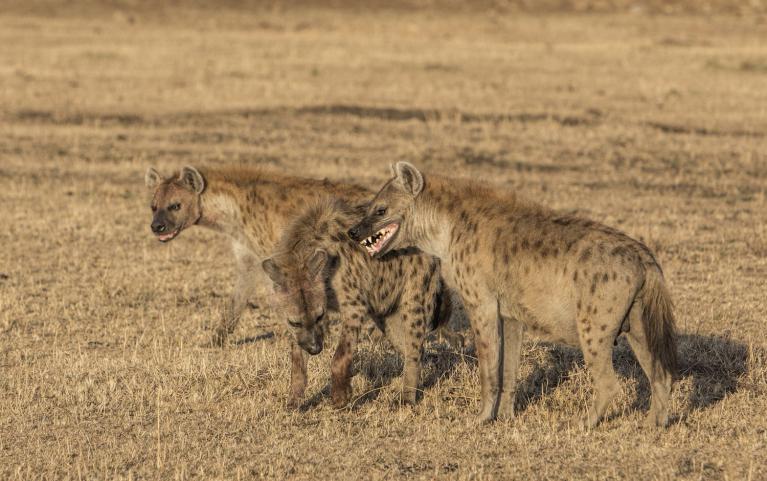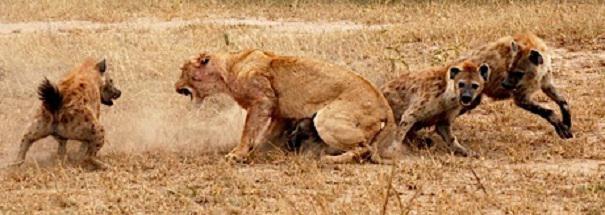The first image is the image on the left, the second image is the image on the right. Given the left and right images, does the statement "No hyena is facing left." hold true? Answer yes or no. No. 